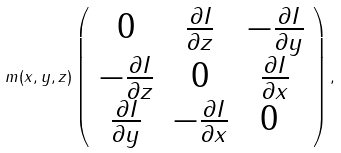Convert formula to latex. <formula><loc_0><loc_0><loc_500><loc_500>m ( x , y , z ) \left ( \begin{array} { c c c } 0 & \frac { \partial I } { \partial z } & - \frac { \partial I } { \partial y } \\ - \frac { \partial I } { \partial z } & 0 & \frac { \partial I } { \partial x } \\ \frac { \partial I } { \partial y } & - \frac { \partial I } { \partial x } & 0 \ \end{array} \right ) ,</formula> 